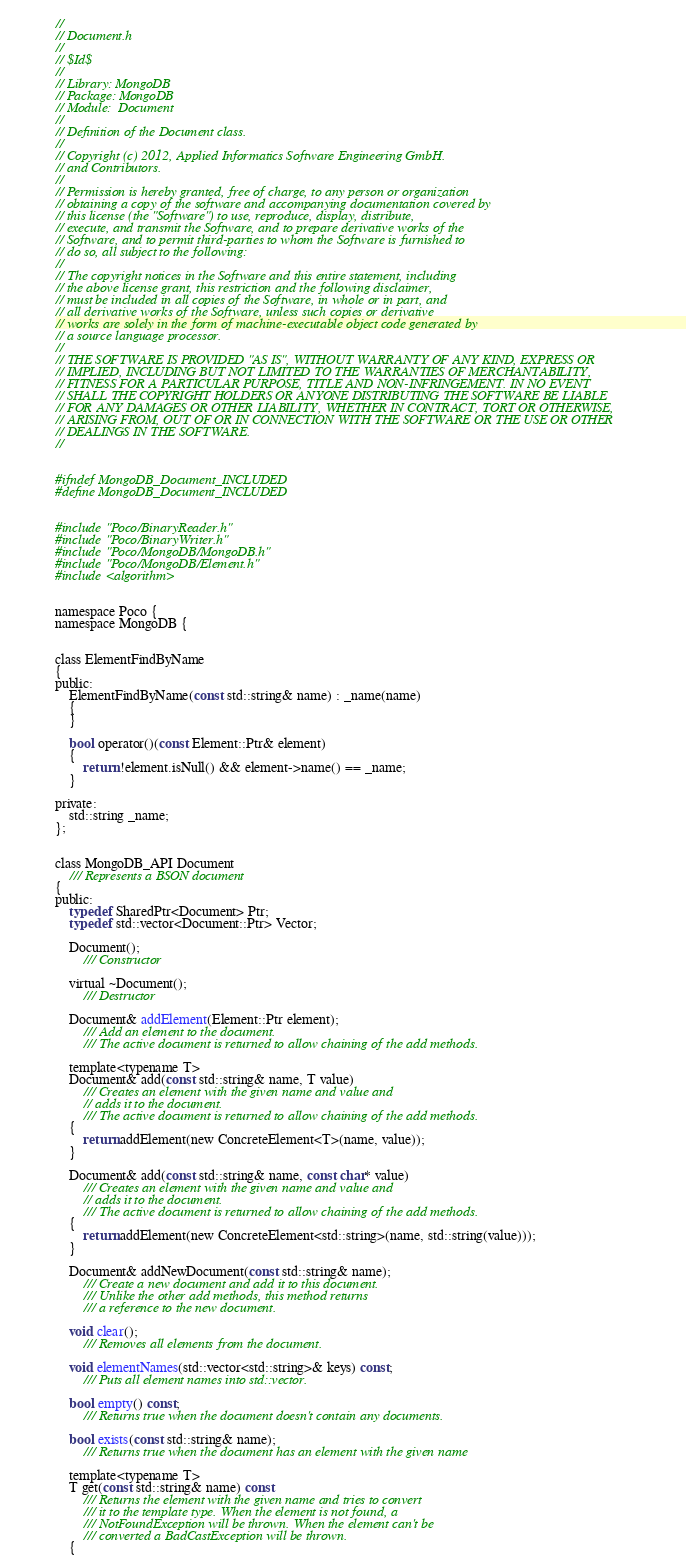<code> <loc_0><loc_0><loc_500><loc_500><_C_>//
// Document.h
//
// $Id$
//
// Library: MongoDB
// Package: MongoDB
// Module:  Document
//
// Definition of the Document class.
//
// Copyright (c) 2012, Applied Informatics Software Engineering GmbH.
// and Contributors.
//
// Permission is hereby granted, free of charge, to any person or organization
// obtaining a copy of the software and accompanying documentation covered by
// this license (the "Software") to use, reproduce, display, distribute,
// execute, and transmit the Software, and to prepare derivative works of the
// Software, and to permit third-parties to whom the Software is furnished to
// do so, all subject to the following:
//
// The copyright notices in the Software and this entire statement, including
// the above license grant, this restriction and the following disclaimer,
// must be included in all copies of the Software, in whole or in part, and
// all derivative works of the Software, unless such copies or derivative
// works are solely in the form of machine-executable object code generated by
// a source language processor.
//
// THE SOFTWARE IS PROVIDED "AS IS", WITHOUT WARRANTY OF ANY KIND, EXPRESS OR
// IMPLIED, INCLUDING BUT NOT LIMITED TO THE WARRANTIES OF MERCHANTABILITY,
// FITNESS FOR A PARTICULAR PURPOSE, TITLE AND NON-INFRINGEMENT. IN NO EVENT
// SHALL THE COPYRIGHT HOLDERS OR ANYONE DISTRIBUTING THE SOFTWARE BE LIABLE
// FOR ANY DAMAGES OR OTHER LIABILITY, WHETHER IN CONTRACT, TORT OR OTHERWISE,
// ARISING FROM, OUT OF OR IN CONNECTION WITH THE SOFTWARE OR THE USE OR OTHER
// DEALINGS IN THE SOFTWARE.
//


#ifndef MongoDB_Document_INCLUDED
#define MongoDB_Document_INCLUDED


#include "Poco/BinaryReader.h"
#include "Poco/BinaryWriter.h"
#include "Poco/MongoDB/MongoDB.h"
#include "Poco/MongoDB/Element.h"
#include <algorithm>


namespace Poco {
namespace MongoDB {


class ElementFindByName
{
public:
	ElementFindByName(const std::string& name) : _name(name)
	{
	}

	bool operator()(const Element::Ptr& element)
	{
		return !element.isNull() && element->name() == _name;
	}

private:
	std::string _name;
};


class MongoDB_API Document
	/// Represents a BSON document
{
public:
	typedef SharedPtr<Document> Ptr;
	typedef std::vector<Document::Ptr> Vector;

	Document();
		/// Constructor

	virtual ~Document();
		/// Destructor

	Document& addElement(Element::Ptr element);
		/// Add an element to the document.
		/// The active document is returned to allow chaining of the add methods.

	template<typename T>
	Document& add(const std::string& name, T value)
		/// Creates an element with the given name and value and
		// adds it to the document.
		/// The active document is returned to allow chaining of the add methods.
	{
		return addElement(new ConcreteElement<T>(name, value));
	}

	Document& add(const std::string& name, const char* value)
		/// Creates an element with the given name and value and
		// adds it to the document.
		/// The active document is returned to allow chaining of the add methods.
	{
		return addElement(new ConcreteElement<std::string>(name, std::string(value)));
	}

	Document& addNewDocument(const std::string& name);
		/// Create a new document and add it to this document.
		/// Unlike the other add methods, this method returns
		/// a reference to the new document.

	void clear();
		/// Removes all elements from the document.

	void elementNames(std::vector<std::string>& keys) const;
		/// Puts all element names into std::vector.

	bool empty() const;
		/// Returns true when the document doesn't contain any documents.

	bool exists(const std::string& name);
		/// Returns true when the document has an element with the given name

	template<typename T>
	T get(const std::string& name) const
		/// Returns the element with the given name and tries to convert
		/// it to the template type. When the element is not found, a
		/// NotFoundException will be thrown. When the element can't be
		/// converted a BadCastException will be thrown.
	{</code> 